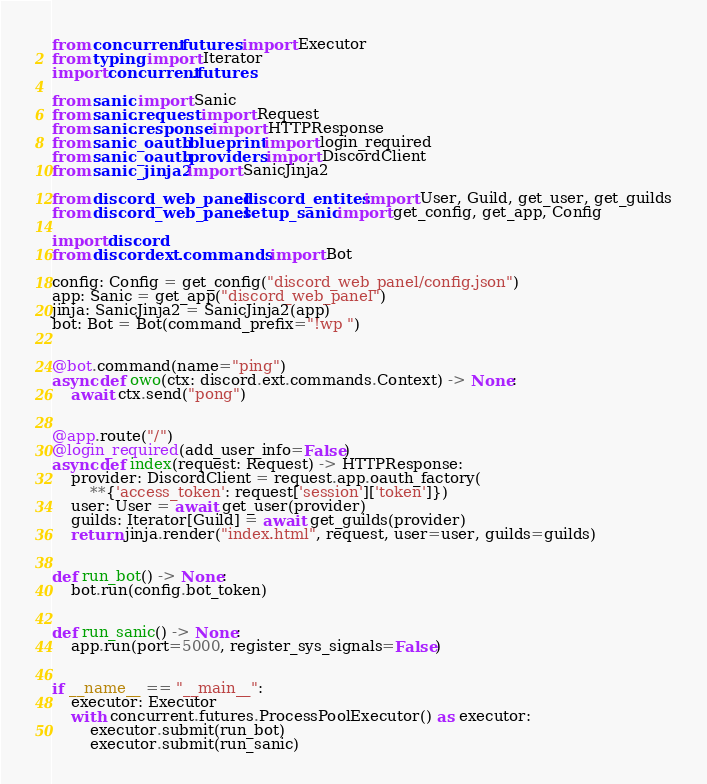Convert code to text. <code><loc_0><loc_0><loc_500><loc_500><_Python_>from concurrent.futures import Executor
from typing import Iterator
import concurrent.futures

from sanic import Sanic
from sanic.request import Request
from sanic.response import HTTPResponse
from sanic_oauth.blueprint import login_required
from sanic_oauth.providers import DiscordClient
from sanic_jinja2 import SanicJinja2

from discord_web_panel.discord_entites import User, Guild, get_user, get_guilds
from discord_web_panel.setup_sanic import get_config, get_app, Config

import discord
from discord.ext.commands import Bot

config: Config = get_config("discord_web_panel/config.json")
app: Sanic = get_app("discord_web_panel")
jinja: SanicJinja2 = SanicJinja2(app)
bot: Bot = Bot(command_prefix="!wp ")


@bot.command(name="ping")
async def owo(ctx: discord.ext.commands.Context) -> None:
    await ctx.send("pong")


@app.route("/")
@login_required(add_user_info=False)
async def index(request: Request) -> HTTPResponse:
    provider: DiscordClient = request.app.oauth_factory(
        **{'access_token': request['session']['token']})
    user: User = await get_user(provider)
    guilds: Iterator[Guild] = await get_guilds(provider)
    return jinja.render("index.html", request, user=user, guilds=guilds)


def run_bot() -> None:
    bot.run(config.bot_token)


def run_sanic() -> None:
    app.run(port=5000, register_sys_signals=False)


if __name__ == "__main__":
    executor: Executor
    with concurrent.futures.ProcessPoolExecutor() as executor:
        executor.submit(run_bot)
        executor.submit(run_sanic)


</code> 